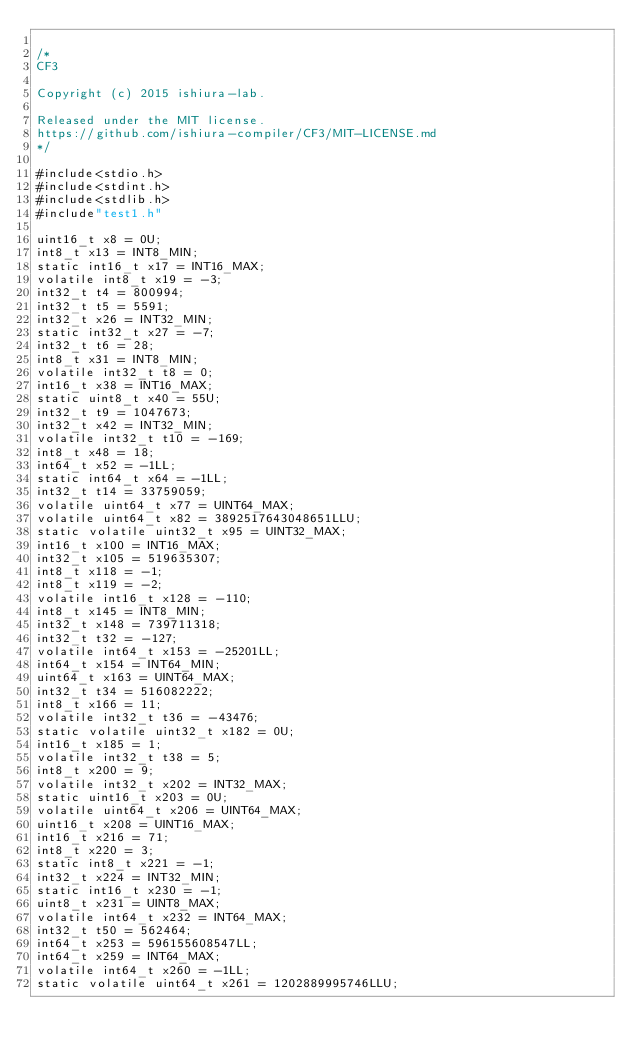Convert code to text. <code><loc_0><loc_0><loc_500><loc_500><_C_>
/*
CF3

Copyright (c) 2015 ishiura-lab.

Released under the MIT license.  
https://github.com/ishiura-compiler/CF3/MIT-LICENSE.md
*/

#include<stdio.h>
#include<stdint.h>
#include<stdlib.h>
#include"test1.h"

uint16_t x8 = 0U;
int8_t x13 = INT8_MIN;
static int16_t x17 = INT16_MAX;
volatile int8_t x19 = -3;
int32_t t4 = 800994;
int32_t t5 = 5591;
int32_t x26 = INT32_MIN;
static int32_t x27 = -7;
int32_t t6 = 28;
int8_t x31 = INT8_MIN;
volatile int32_t t8 = 0;
int16_t x38 = INT16_MAX;
static uint8_t x40 = 55U;
int32_t t9 = 1047673;
int32_t x42 = INT32_MIN;
volatile int32_t t10 = -169;
int8_t x48 = 18;
int64_t x52 = -1LL;
static int64_t x64 = -1LL;
int32_t t14 = 33759059;
volatile uint64_t x77 = UINT64_MAX;
volatile uint64_t x82 = 3892517643048651LLU;
static volatile uint32_t x95 = UINT32_MAX;
int16_t x100 = INT16_MAX;
int32_t x105 = 519635307;
int8_t x118 = -1;
int8_t x119 = -2;
volatile int16_t x128 = -110;
int8_t x145 = INT8_MIN;
int32_t x148 = 739711318;
int32_t t32 = -127;
volatile int64_t x153 = -25201LL;
int64_t x154 = INT64_MIN;
uint64_t x163 = UINT64_MAX;
int32_t t34 = 516082222;
int8_t x166 = 11;
volatile int32_t t36 = -43476;
static volatile uint32_t x182 = 0U;
int16_t x185 = 1;
volatile int32_t t38 = 5;
int8_t x200 = 9;
volatile int32_t x202 = INT32_MAX;
static uint16_t x203 = 0U;
volatile uint64_t x206 = UINT64_MAX;
uint16_t x208 = UINT16_MAX;
int16_t x216 = 71;
int8_t x220 = 3;
static int8_t x221 = -1;
int32_t x224 = INT32_MIN;
static int16_t x230 = -1;
uint8_t x231 = UINT8_MAX;
volatile int64_t x232 = INT64_MAX;
int32_t t50 = 562464;
int64_t x253 = 596155608547LL;
int64_t x259 = INT64_MAX;
volatile int64_t x260 = -1LL;
static volatile uint64_t x261 = 1202889995746LLU;</code> 